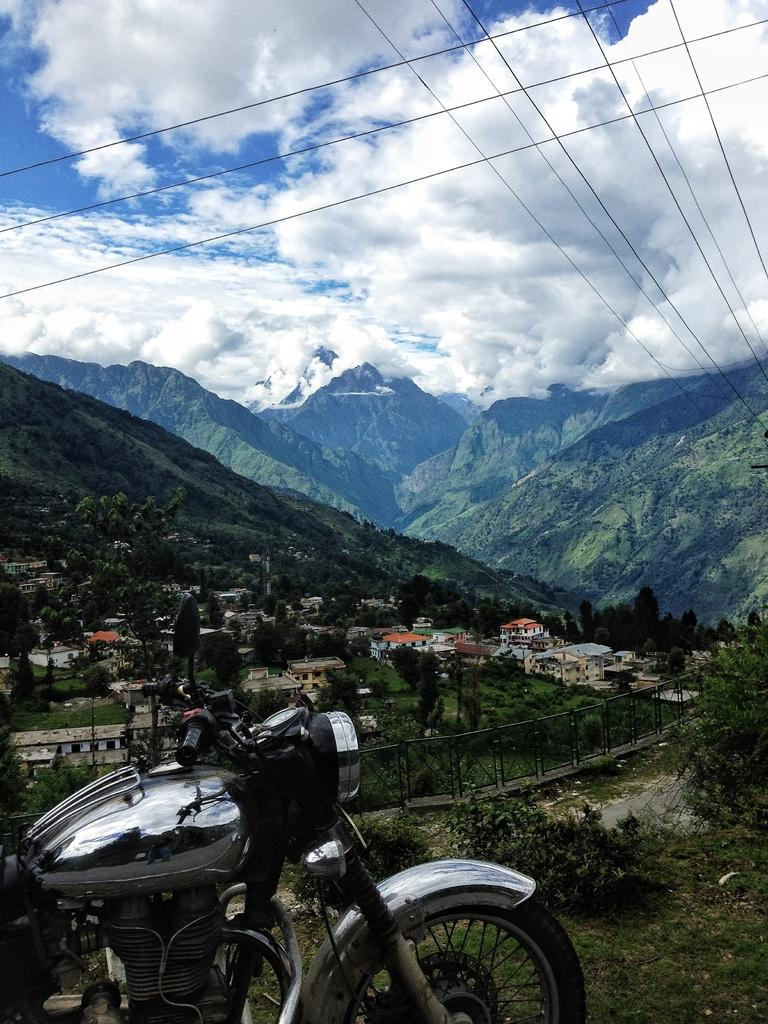What is the main subject in the foreground of the image? There is a motorbike in the foreground of the image. What can be seen in the background of the image? Buildings, trees, fencing, mountains, and the sky are visible in the background of the image. Can you describe the sky in the image? The sky is visible in the background of the image, and there is a cloud present. What else is present in the image besides the motorbike and the background elements? Cables are present in the image. How many chairs are placed under the motorbike in the image? There are no chairs present under the motorbike in the image. What type of underwear is visible on the motorbike in the image? There is no underwear present on the motorbike in the image. 